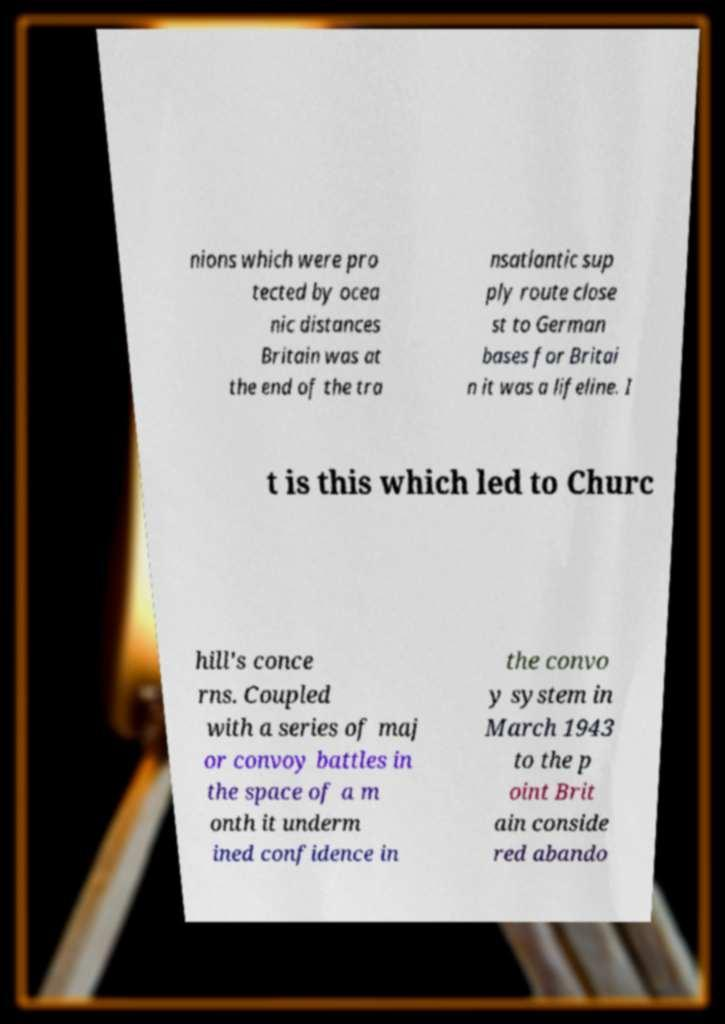There's text embedded in this image that I need extracted. Can you transcribe it verbatim? nions which were pro tected by ocea nic distances Britain was at the end of the tra nsatlantic sup ply route close st to German bases for Britai n it was a lifeline. I t is this which led to Churc hill's conce rns. Coupled with a series of maj or convoy battles in the space of a m onth it underm ined confidence in the convo y system in March 1943 to the p oint Brit ain conside red abando 